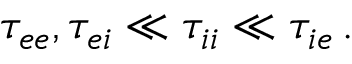Convert formula to latex. <formula><loc_0><loc_0><loc_500><loc_500>\tau _ { e e } , \tau _ { e i } \ll \tau _ { i i } \ll \tau _ { i e } \, .</formula> 